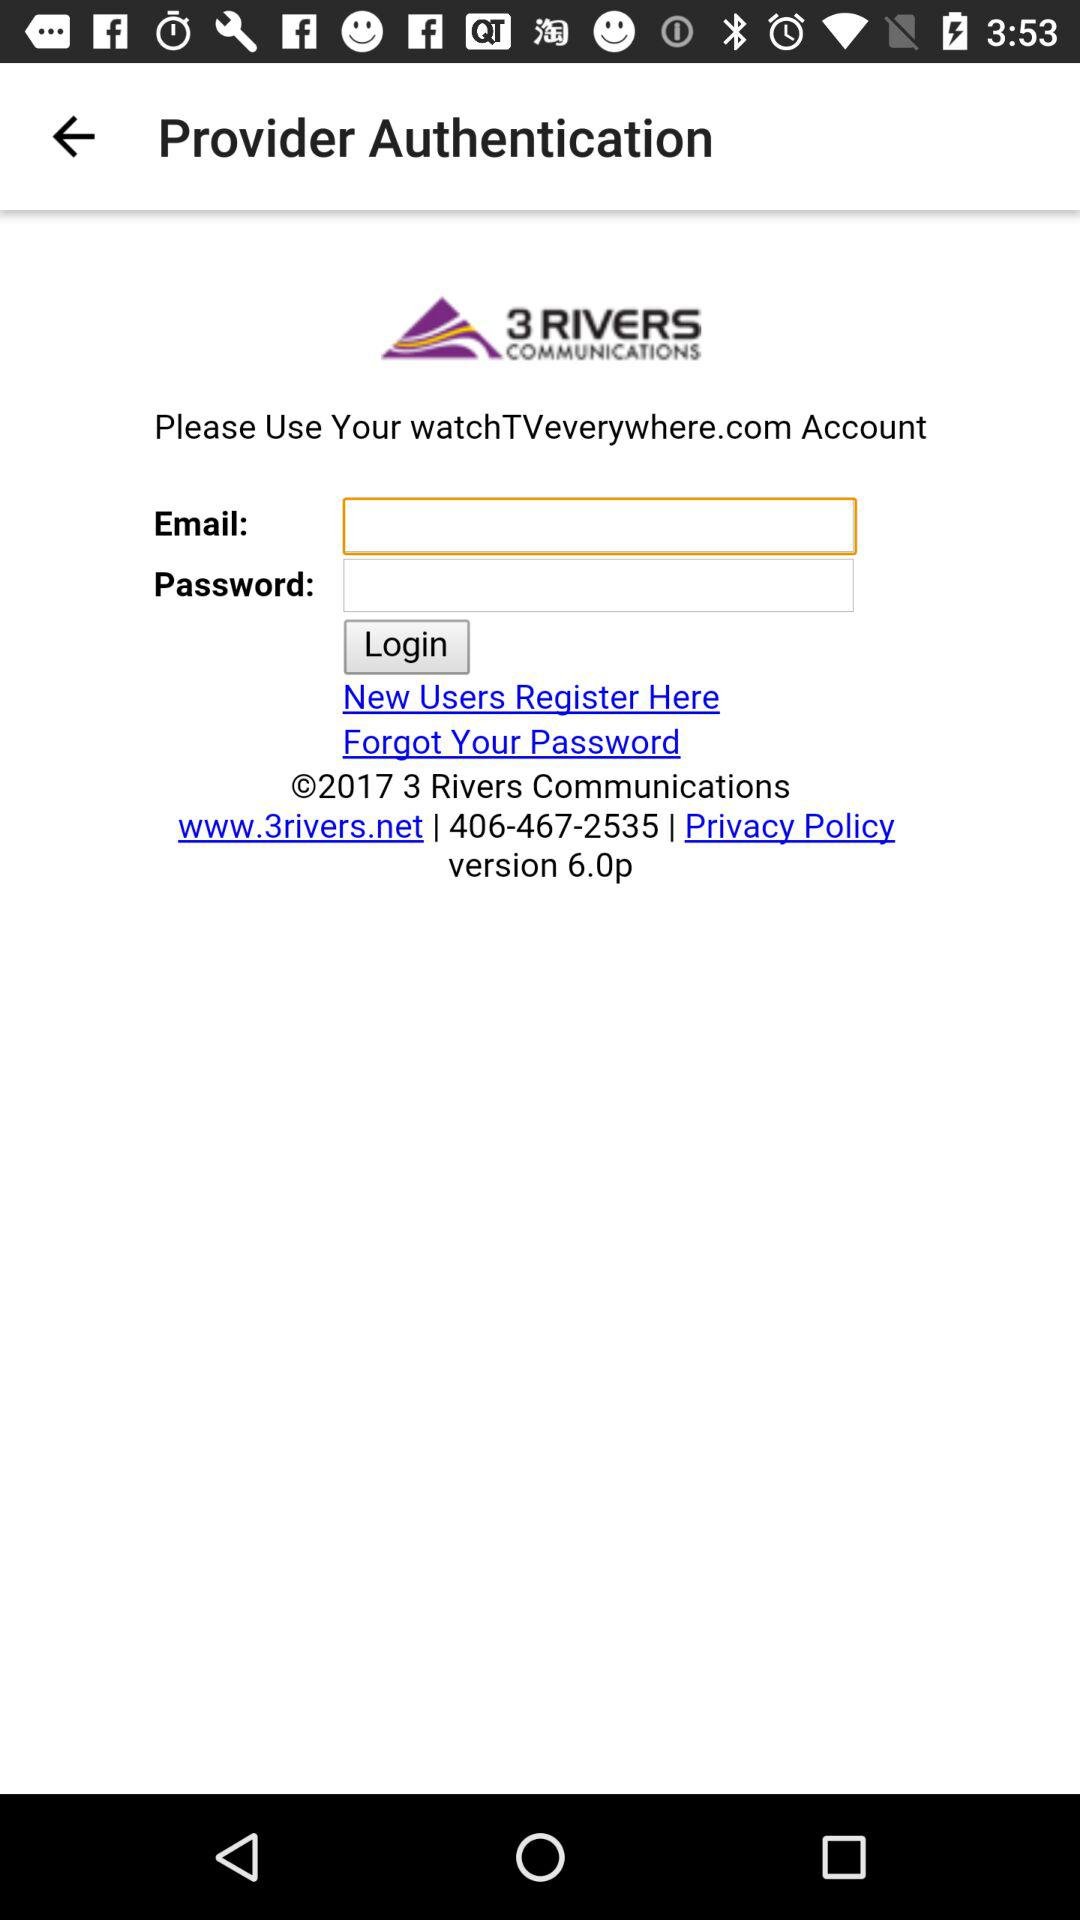What is the contact number? The contact number is 406-467-2535. 